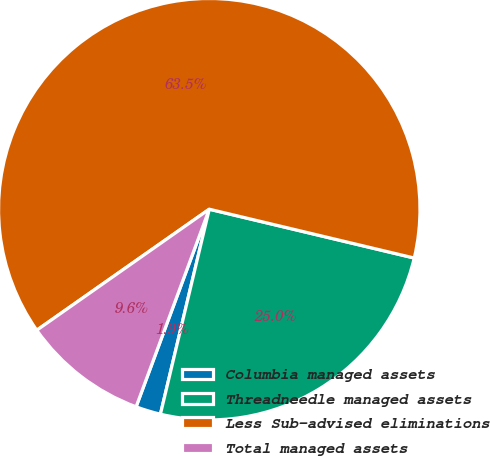Convert chart to OTSL. <chart><loc_0><loc_0><loc_500><loc_500><pie_chart><fcel>Columbia managed assets<fcel>Threadneedle managed assets<fcel>Less Sub-advised eliminations<fcel>Total managed assets<nl><fcel>1.92%<fcel>25.0%<fcel>63.46%<fcel>9.62%<nl></chart> 